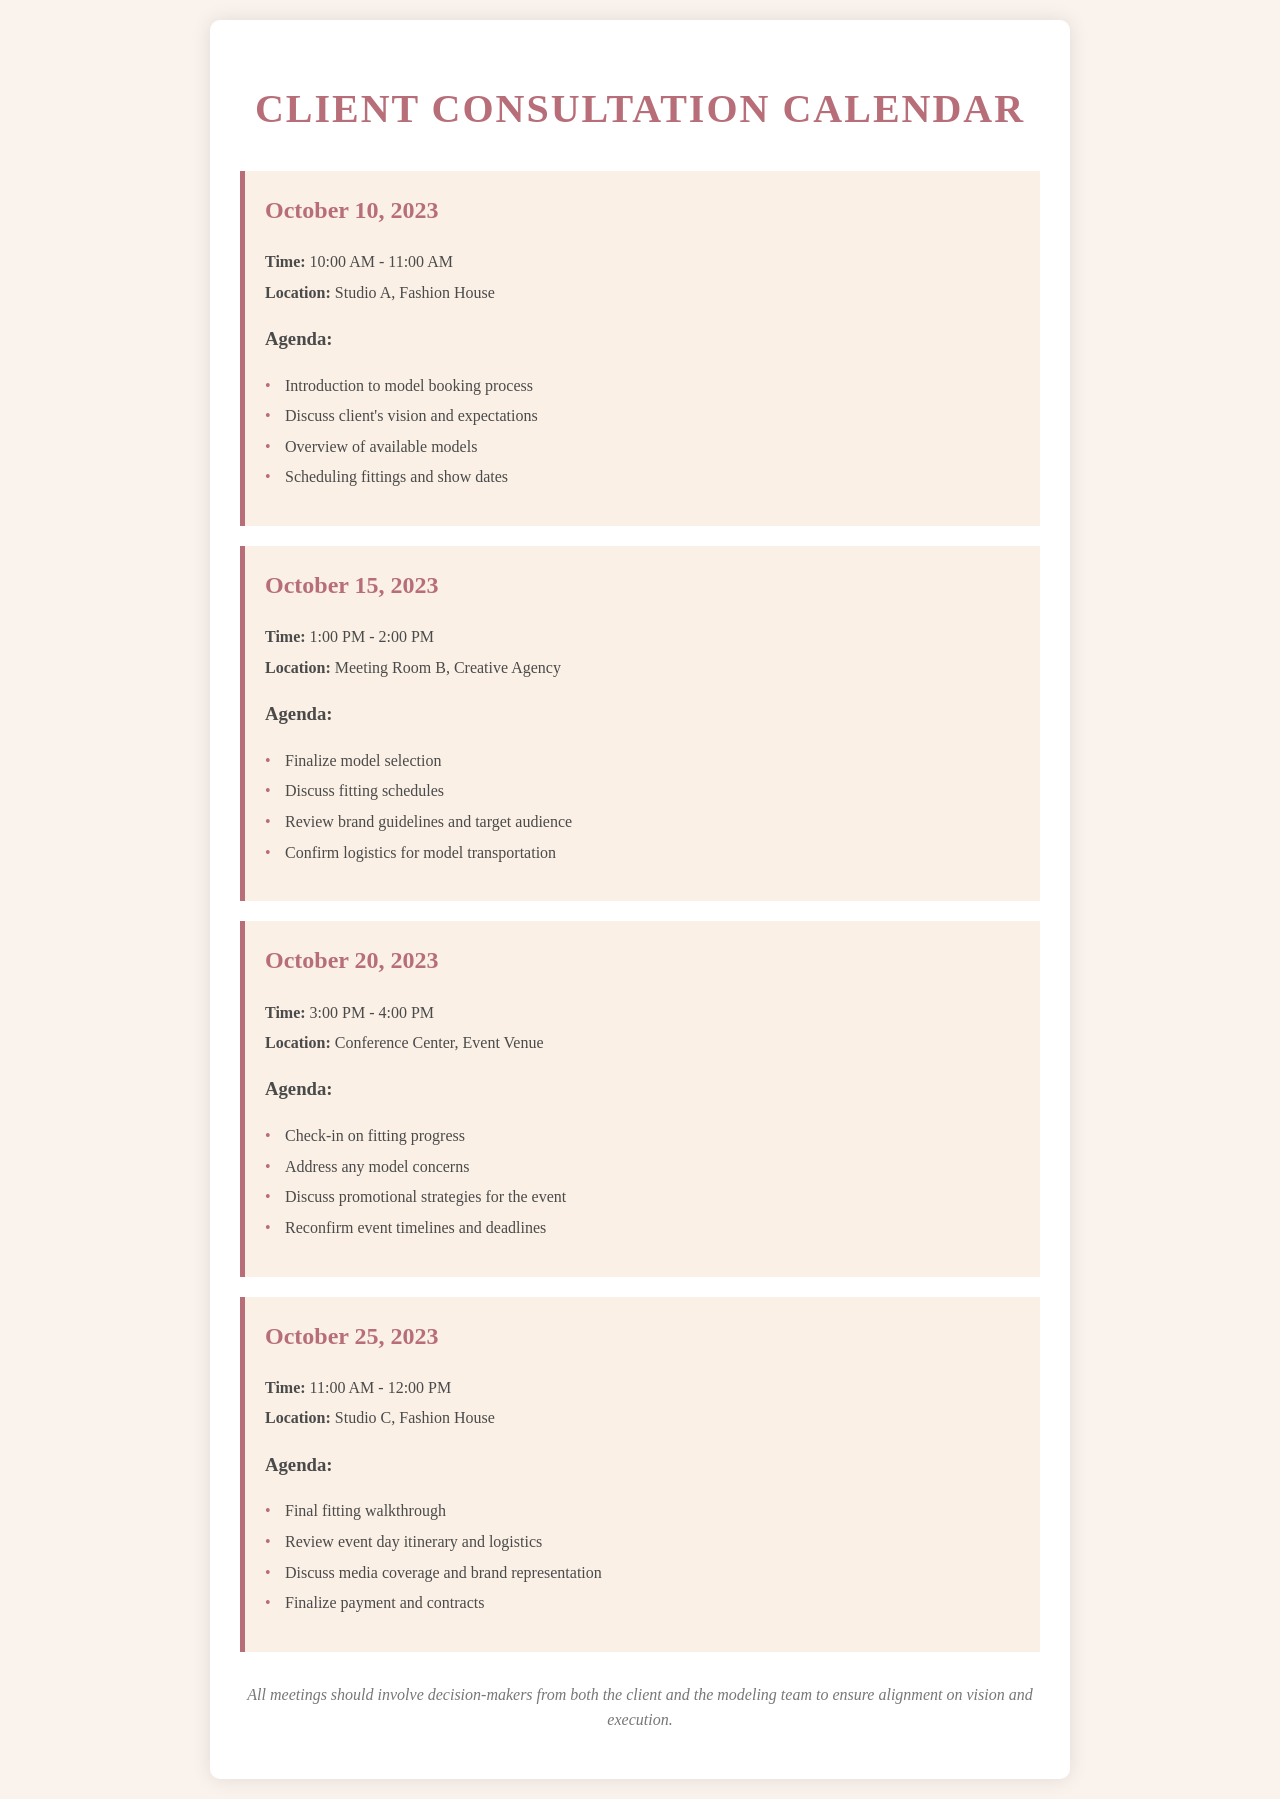What is the date of the first meeting? The first meeting is scheduled for October 10, 2023, as indicated in the document.
Answer: October 10, 2023 What time does the meeting on October 15, 2023, start? The meeting on October 15, 2023, starts at 1:00 PM, as stated in the document.
Answer: 1:00 PM Where is the fitting walkthrough meeting held? The final fitting walkthrough meeting is held at Studio C, Fashion House, according to the document details.
Answer: Studio C, Fashion House How many agenda items are listed for the meeting on October 25, 2023? There are four agenda items listed for the October 25, 2023 meeting, as per the document.
Answer: 4 What is a key topic discussed in the meeting on October 20, 2023? A key topic discussed in the meeting on October 20, 2023, is addressing any model concerns, as found in the agenda.
Answer: Address any model concerns What should all meetings involve according to the notes? According to the notes, all meetings should involve decision-makers from both the client and the modeling team.
Answer: Decision-makers from both the client and the modeling team What is the purpose of the meeting scheduled for October 25, 2023? The purpose of the meeting scheduled for October 25, 2023, includes final fitting walkthrough and reviewing event day logistics, as detailed in the agenda.
Answer: Final fitting walkthrough and reviewing event day logistics How long is the meeting on October 10, 2023? The meeting on October 10, 2023, is scheduled for one hour, based on the stated meeting times.
Answer: 1 hour 